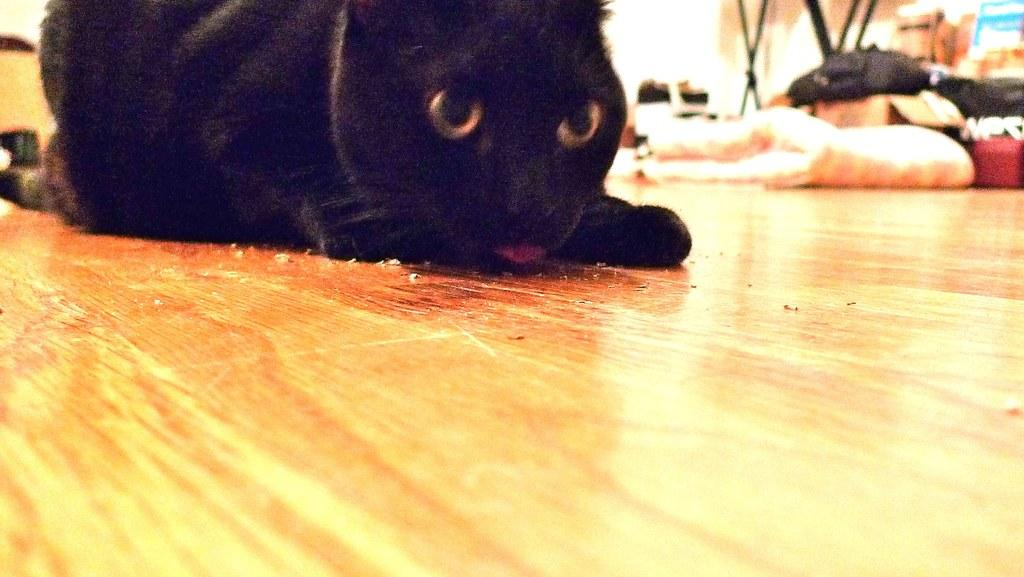What type of animal is in the foreground of the image? There is a black color cat in the foreground of the image. What is the cat sitting on? The cat is on a wooden surface. What can be seen in the background of the image? There is a bag and a cardboard box in the background of the image. Are there any other objects visible in the image? Yes, there are other objects visible at the top of the image. What type of beef is being prepared in the image? There is no beef or any indication of food preparation in the image; it features a black color cat on a wooden surface. What type of cloth is draped over the cardboard box in the image? There is no cloth visible in the image, as it only shows a black color cat, a wooden surface, a bag, a cardboard box, and other unspecified objects. 